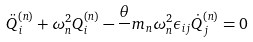Convert formula to latex. <formula><loc_0><loc_0><loc_500><loc_500>\ddot { Q } _ { i } ^ { ( n ) } + \omega _ { n } ^ { 2 } Q _ { i } ^ { ( n ) } - \frac { \theta } { } m _ { n } \omega _ { n } ^ { 2 } \epsilon _ { i j } \dot { Q } _ { j } ^ { ( n ) } = 0</formula> 